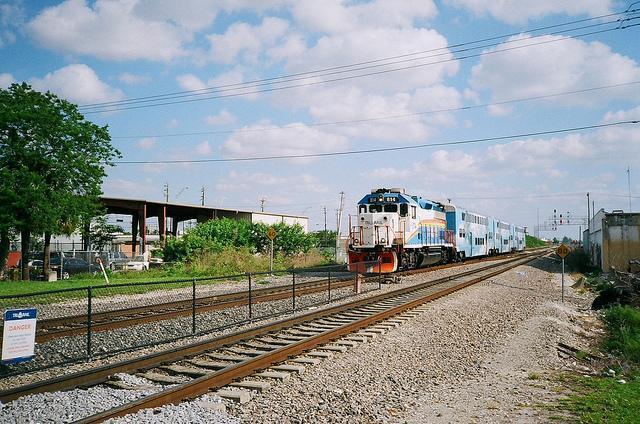How many train tracks is there?
Give a very brief answer. 2. How many tracks are visible?
Give a very brief answer. 2. How many trees are seen?
Give a very brief answer. 1. How many bowls are there?
Give a very brief answer. 0. 